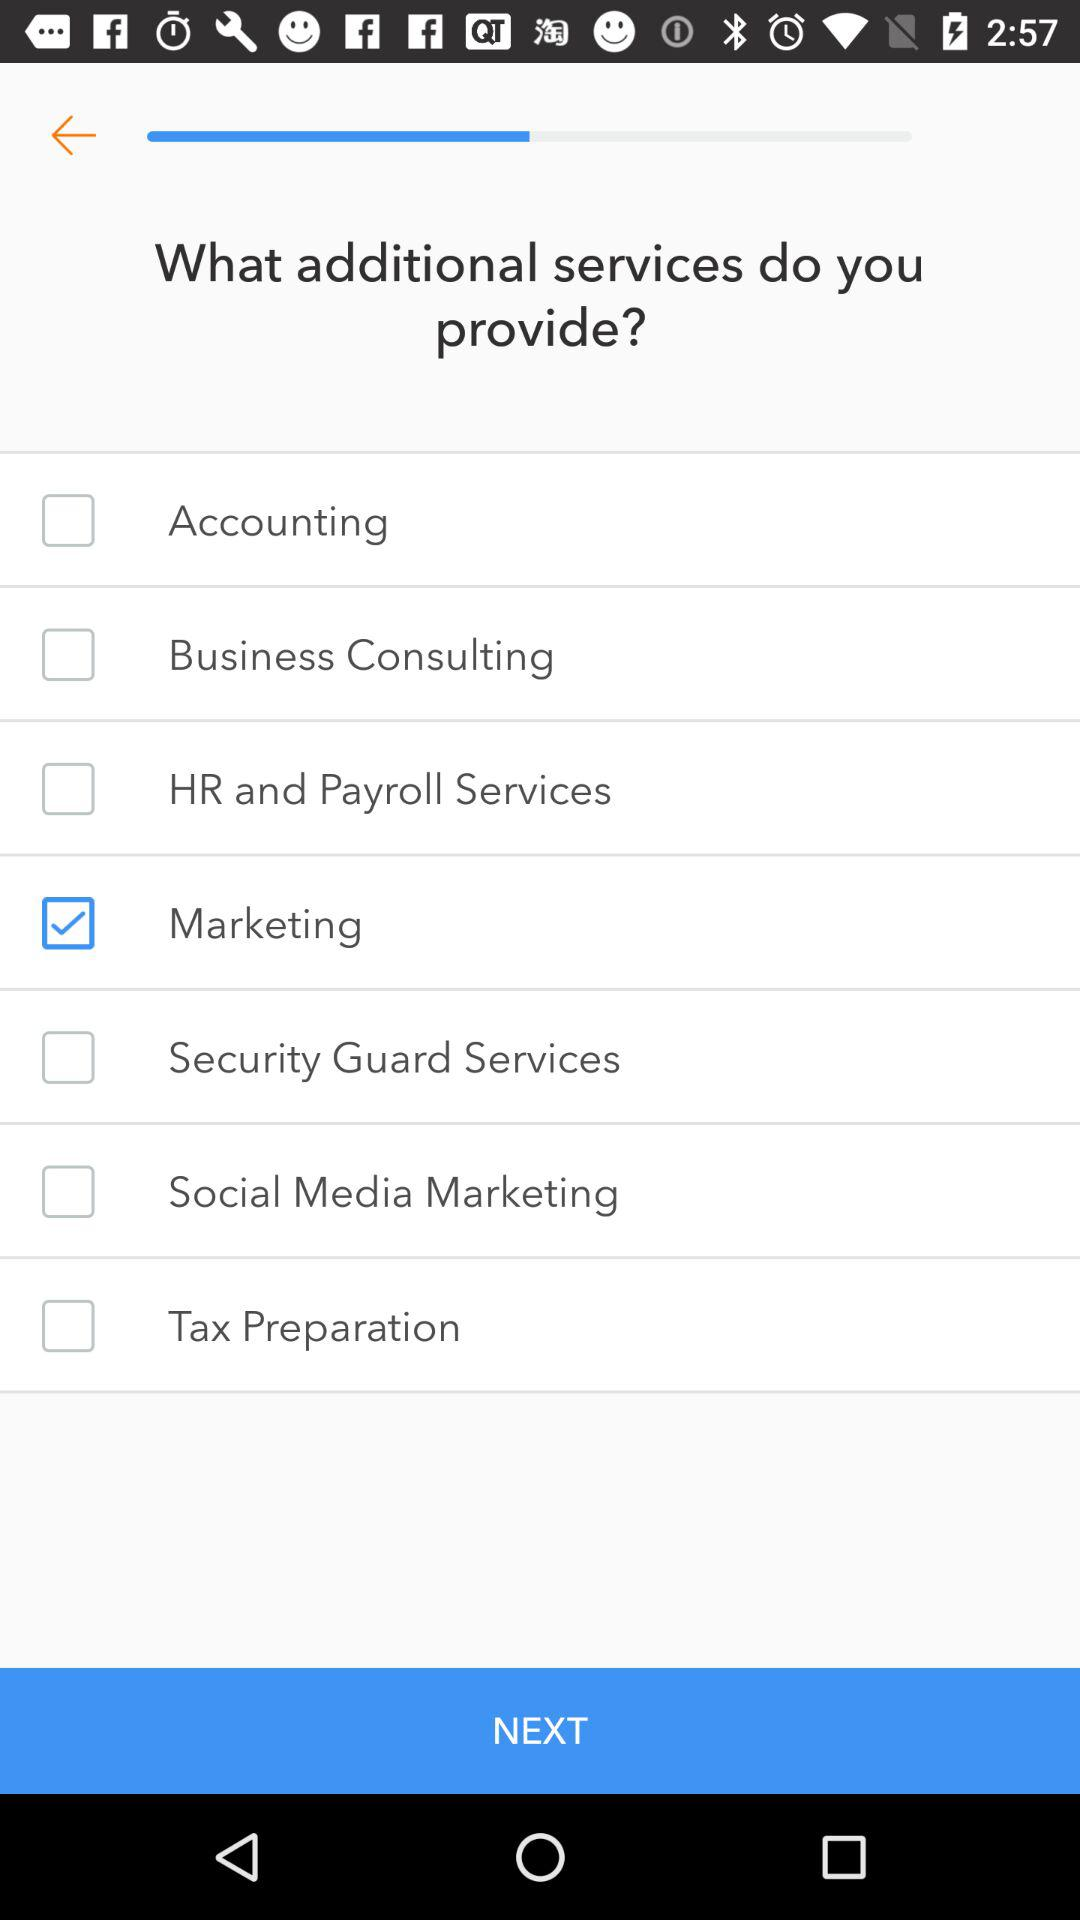Which additional services are selected? The selected additional service is "Marketing". 